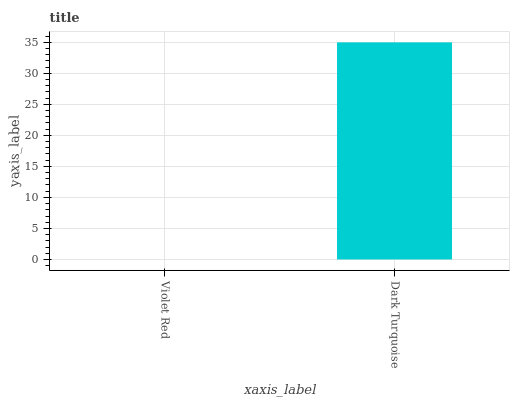Is Violet Red the minimum?
Answer yes or no. Yes. Is Dark Turquoise the maximum?
Answer yes or no. Yes. Is Dark Turquoise the minimum?
Answer yes or no. No. Is Dark Turquoise greater than Violet Red?
Answer yes or no. Yes. Is Violet Red less than Dark Turquoise?
Answer yes or no. Yes. Is Violet Red greater than Dark Turquoise?
Answer yes or no. No. Is Dark Turquoise less than Violet Red?
Answer yes or no. No. Is Dark Turquoise the high median?
Answer yes or no. Yes. Is Violet Red the low median?
Answer yes or no. Yes. Is Violet Red the high median?
Answer yes or no. No. Is Dark Turquoise the low median?
Answer yes or no. No. 